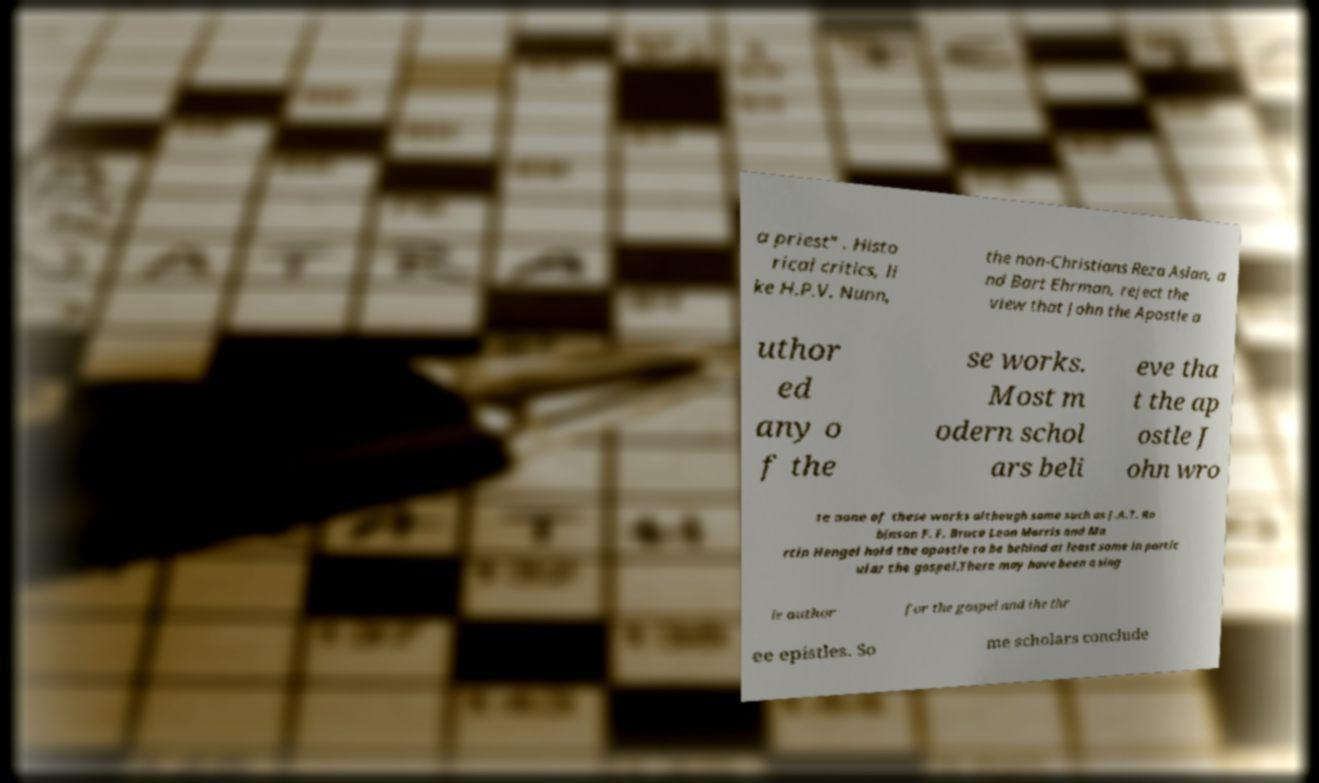I need the written content from this picture converted into text. Can you do that? a priest" . Histo rical critics, li ke H.P.V. Nunn, the non-Christians Reza Aslan, a nd Bart Ehrman, reject the view that John the Apostle a uthor ed any o f the se works. Most m odern schol ars beli eve tha t the ap ostle J ohn wro te none of these works although some such as J.A.T. Ro binson F. F. Bruce Leon Morris and Ma rtin Hengel hold the apostle to be behind at least some in partic ular the gospel.There may have been a sing le author for the gospel and the thr ee epistles. So me scholars conclude 